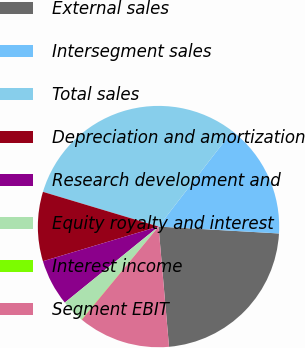Convert chart to OTSL. <chart><loc_0><loc_0><loc_500><loc_500><pie_chart><fcel>External sales<fcel>Intersegment sales<fcel>Total sales<fcel>Depreciation and amortization<fcel>Research development and<fcel>Equity royalty and interest<fcel>Interest income<fcel>Segment EBIT<nl><fcel>22.7%<fcel>15.44%<fcel>30.82%<fcel>9.28%<fcel>6.21%<fcel>3.13%<fcel>0.05%<fcel>12.36%<nl></chart> 